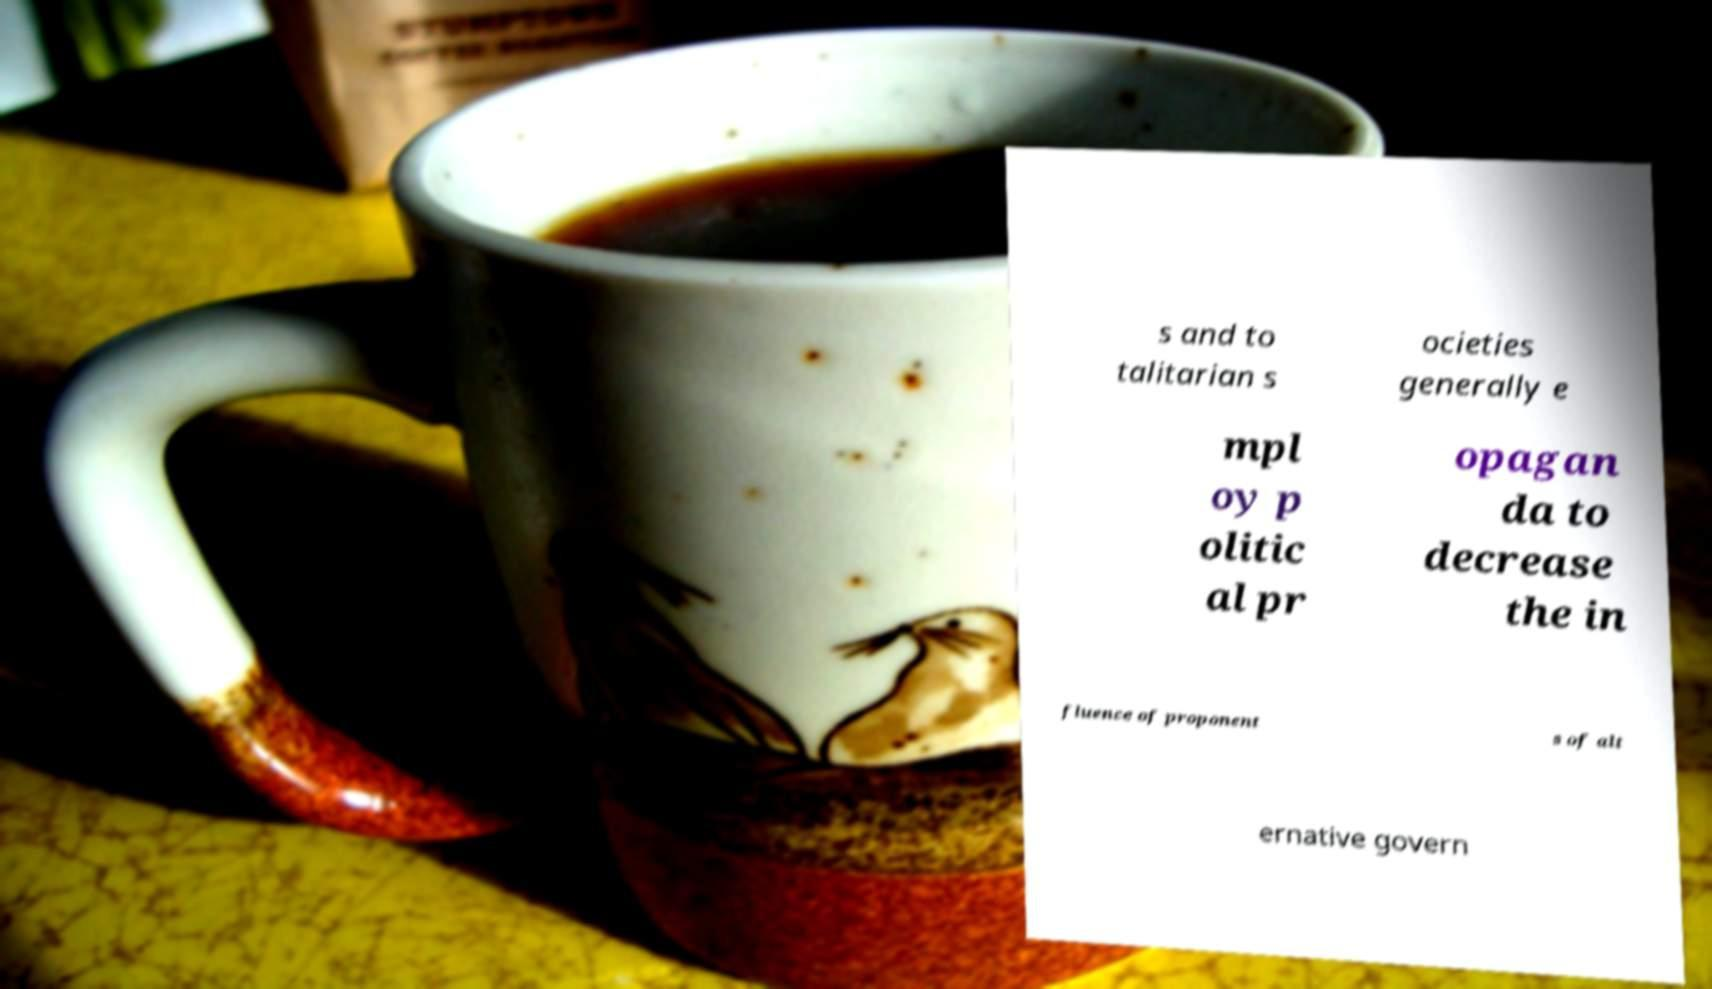Could you assist in decoding the text presented in this image and type it out clearly? s and to talitarian s ocieties generally e mpl oy p olitic al pr opagan da to decrease the in fluence of proponent s of alt ernative govern 